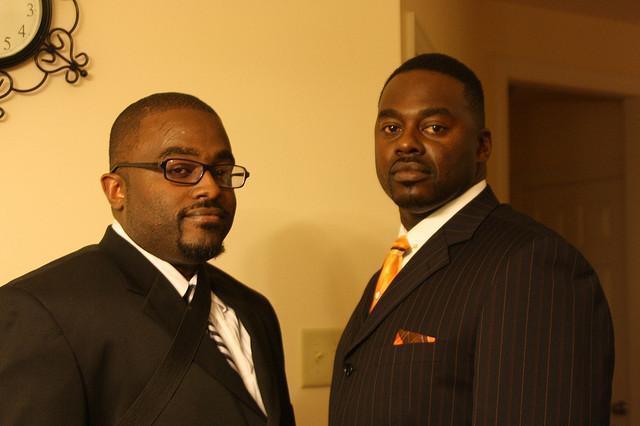How many people can you see?
Give a very brief answer. 2. How many books on the hand are there?
Give a very brief answer. 0. 